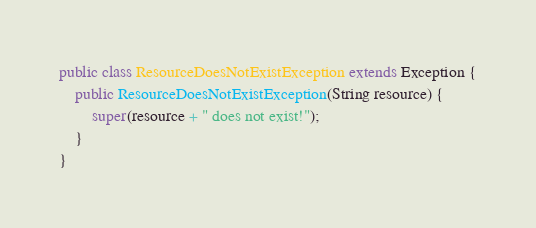Convert code to text. <code><loc_0><loc_0><loc_500><loc_500><_Java_>public class ResourceDoesNotExistException extends Exception {
    public ResourceDoesNotExistException(String resource) {
        super(resource + " does not exist!");
    }
}</code> 